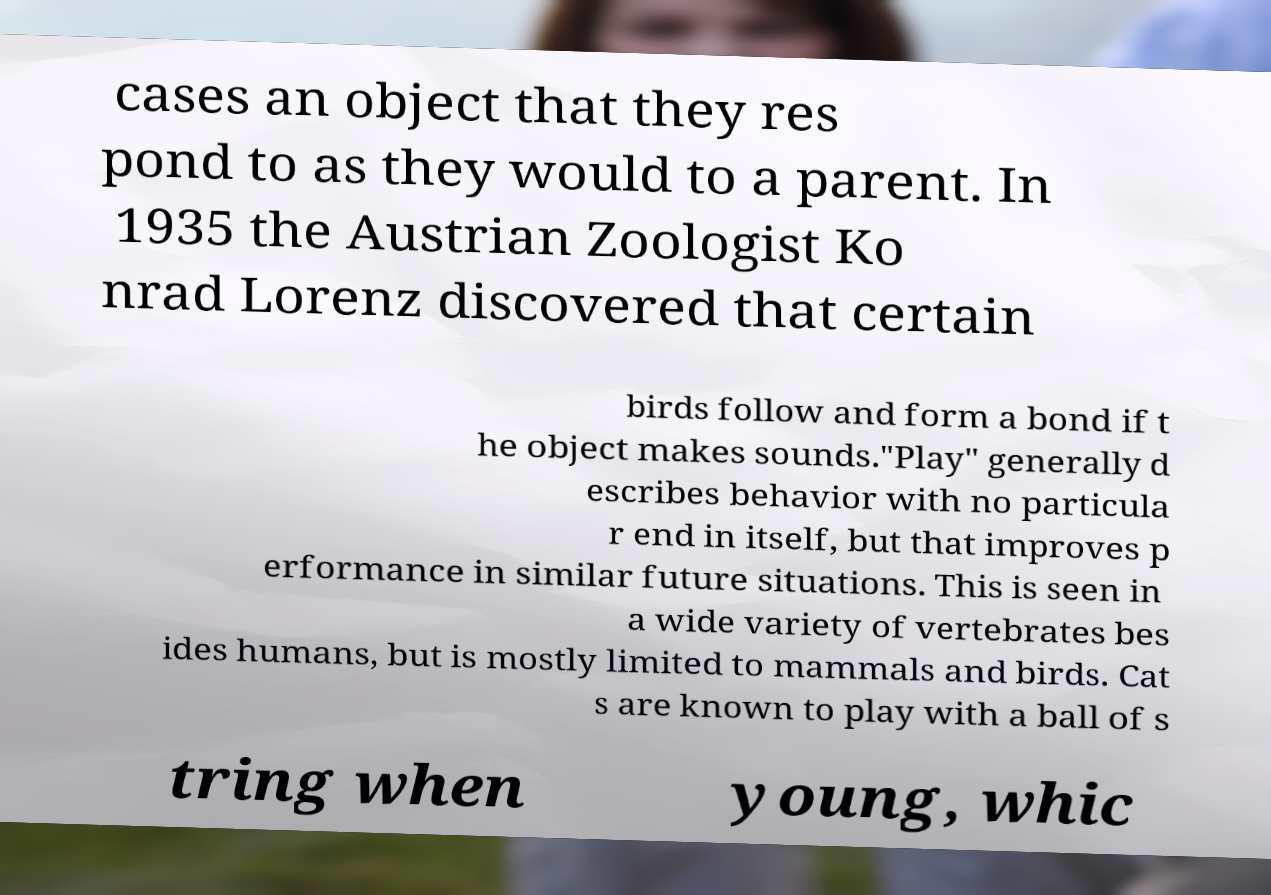What messages or text are displayed in this image? I need them in a readable, typed format. cases an object that they res pond to as they would to a parent. In 1935 the Austrian Zoologist Ko nrad Lorenz discovered that certain birds follow and form a bond if t he object makes sounds."Play" generally d escribes behavior with no particula r end in itself, but that improves p erformance in similar future situations. This is seen in a wide variety of vertebrates bes ides humans, but is mostly limited to mammals and birds. Cat s are known to play with a ball of s tring when young, whic 